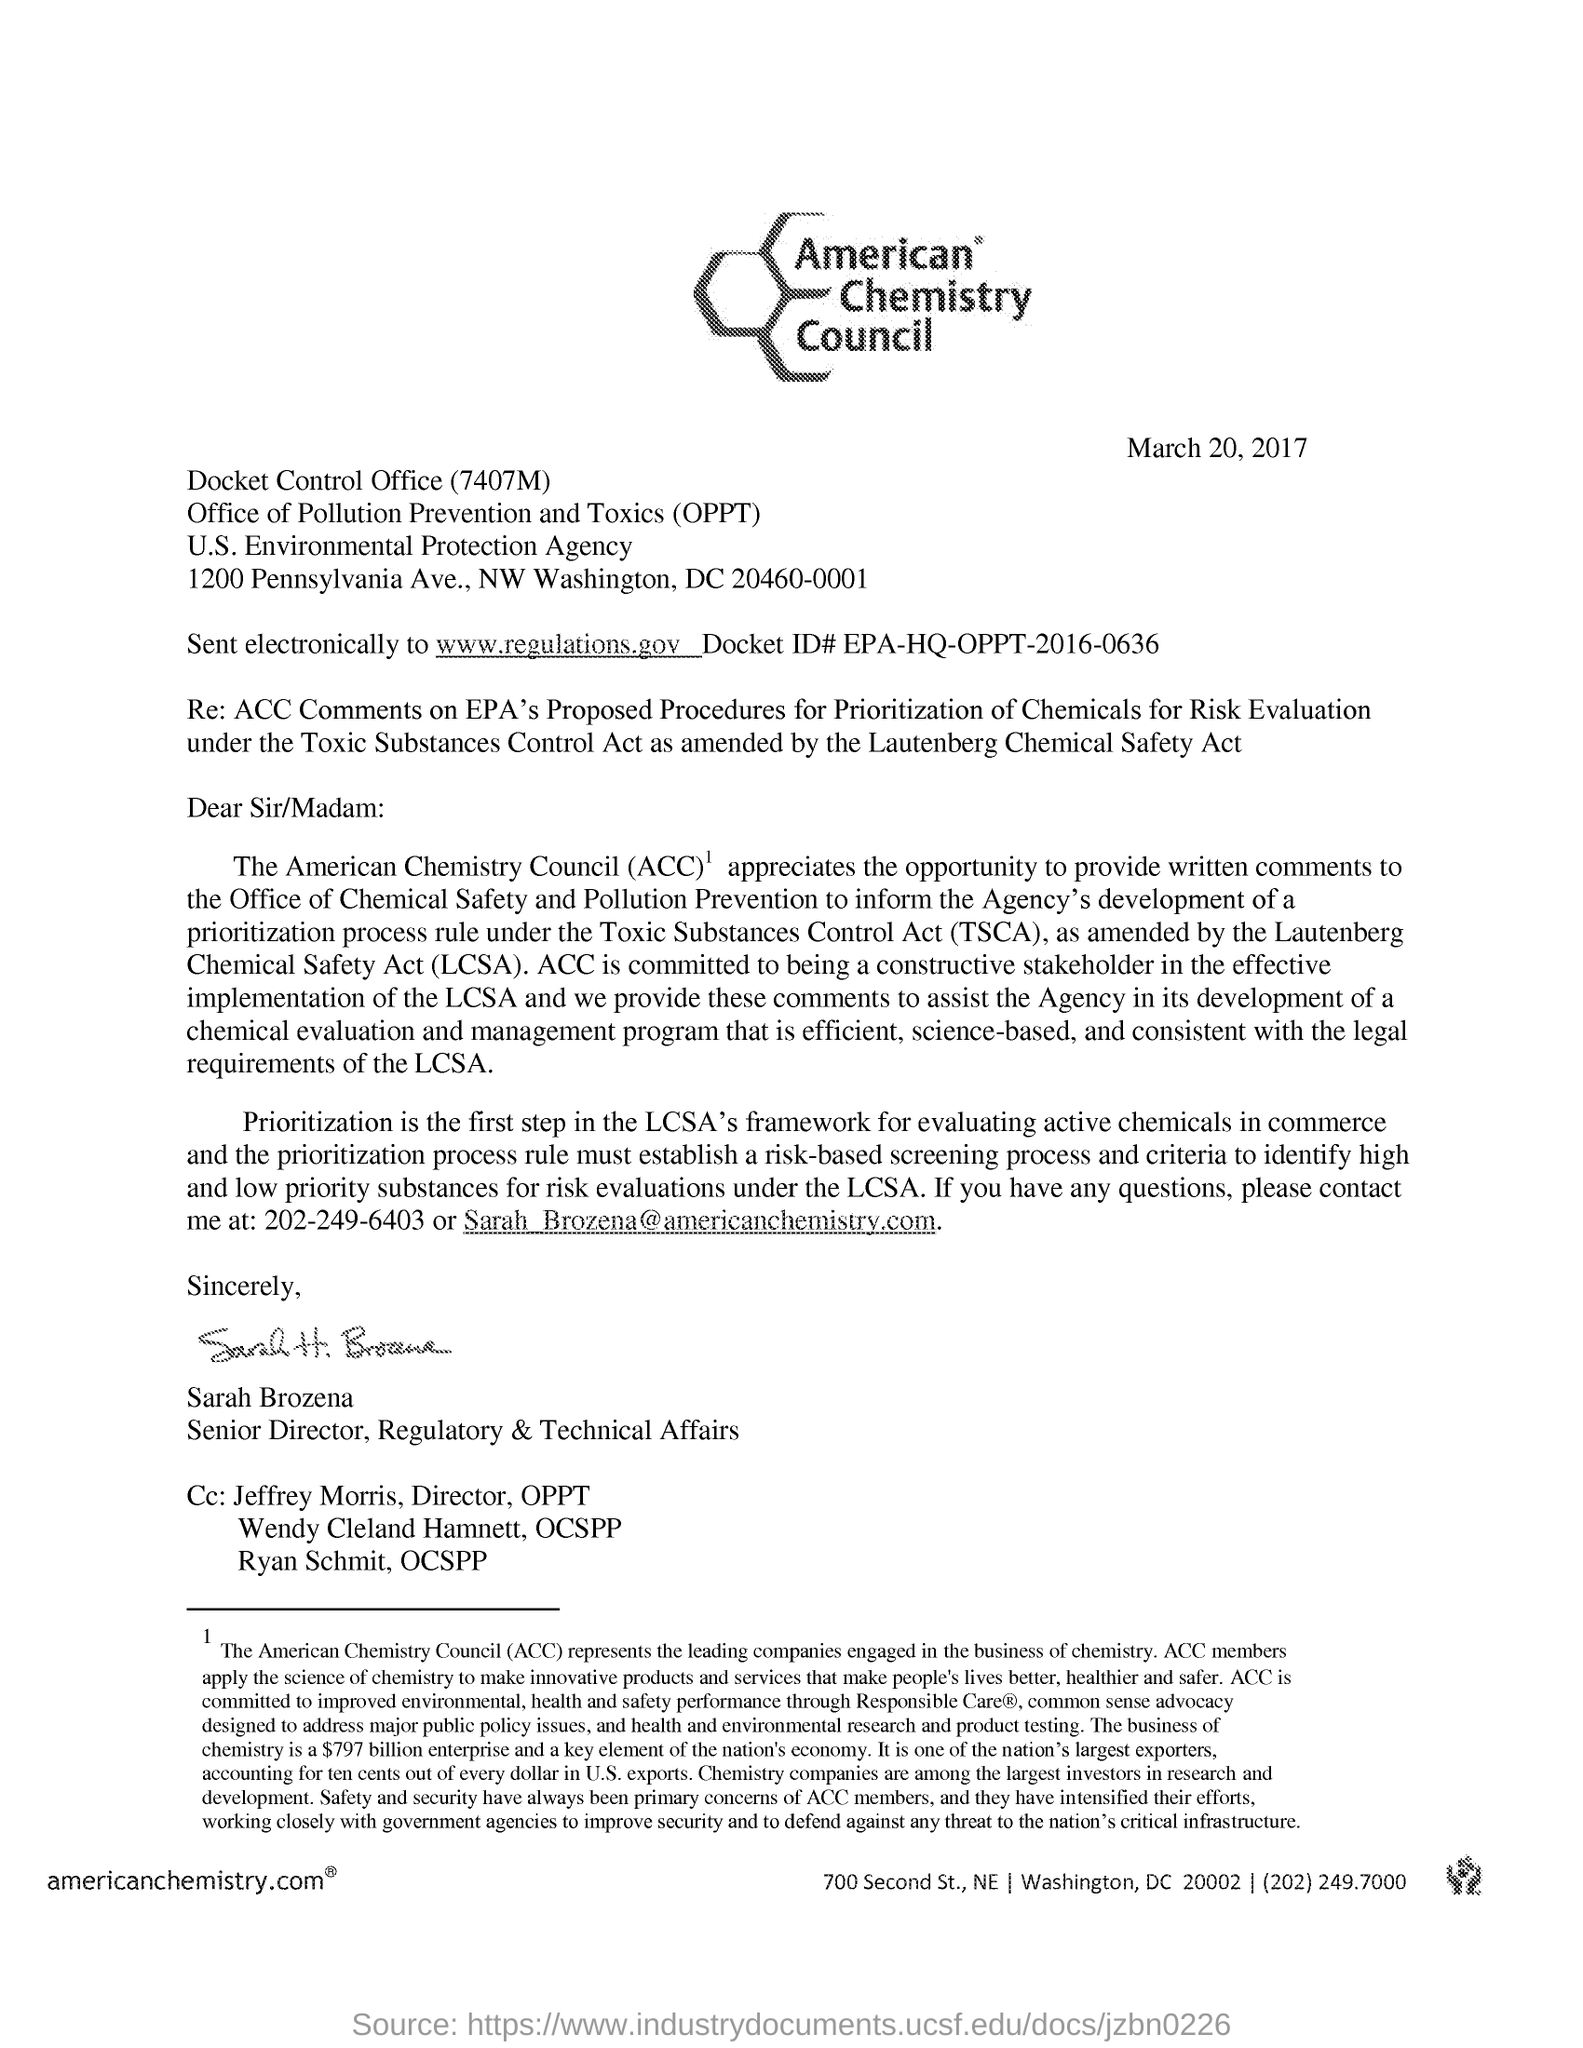What is the heading of the letter?
Make the answer very short. American Chemistry Council. What is the date mentioned?
Make the answer very short. March 20, 2017. By whom is this letter written?
Provide a short and direct response. Sarah Brozena. 